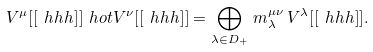<formula> <loc_0><loc_0><loc_500><loc_500>V ^ { \mu } [ [ \ h h h ] ] \ h o t V ^ { \nu } [ [ \ h h h ] ] = \bigoplus _ { \lambda \in D _ { + } } \, m _ { \lambda } ^ { \mu \nu } \, V ^ { \lambda } [ [ \ h h h ] ] .</formula> 